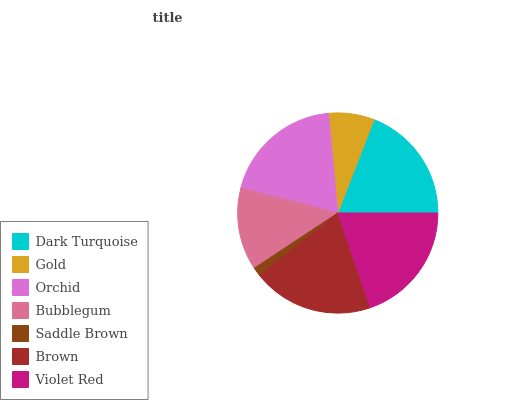Is Saddle Brown the minimum?
Answer yes or no. Yes. Is Violet Red the maximum?
Answer yes or no. Yes. Is Gold the minimum?
Answer yes or no. No. Is Gold the maximum?
Answer yes or no. No. Is Dark Turquoise greater than Gold?
Answer yes or no. Yes. Is Gold less than Dark Turquoise?
Answer yes or no. Yes. Is Gold greater than Dark Turquoise?
Answer yes or no. No. Is Dark Turquoise less than Gold?
Answer yes or no. No. Is Dark Turquoise the high median?
Answer yes or no. Yes. Is Dark Turquoise the low median?
Answer yes or no. Yes. Is Violet Red the high median?
Answer yes or no. No. Is Orchid the low median?
Answer yes or no. No. 